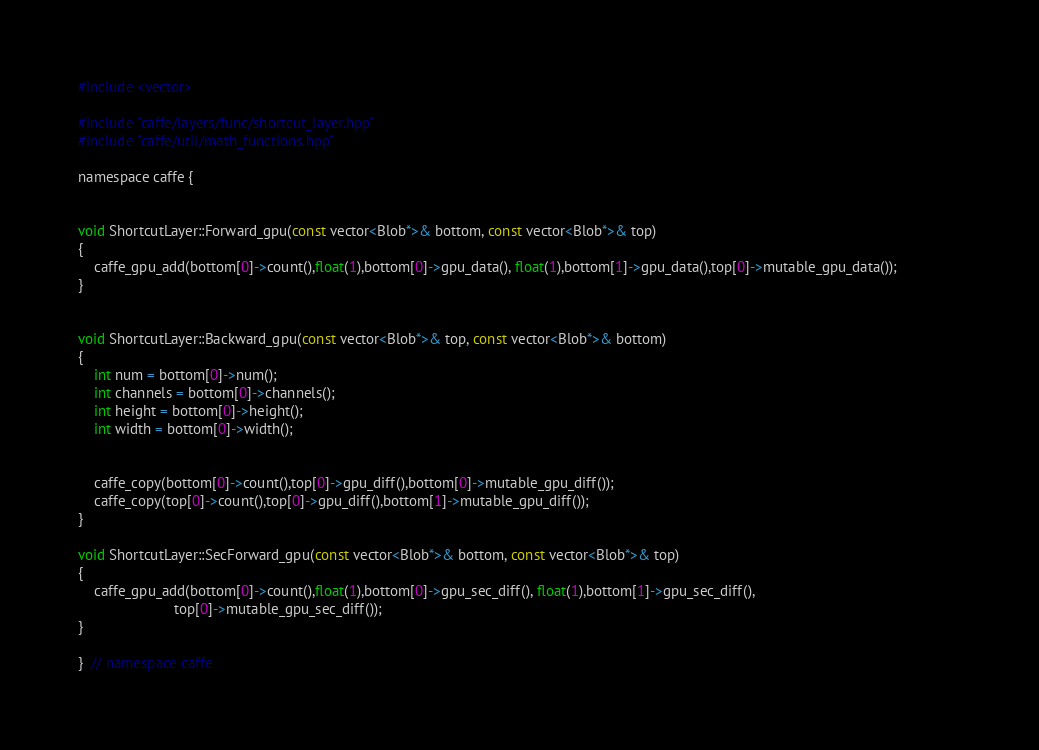<code> <loc_0><loc_0><loc_500><loc_500><_Cuda_>#include <vector>

#include "caffe/layers/func/shortcut_layer.hpp"
#include "caffe/util/math_functions.hpp"

namespace caffe {


void ShortcutLayer::Forward_gpu(const vector<Blob*>& bottom, const vector<Blob*>& top) 
{	
	caffe_gpu_add(bottom[0]->count(),float(1),bottom[0]->gpu_data(), float(1),bottom[1]->gpu_data(),top[0]->mutable_gpu_data());				
}


void ShortcutLayer::Backward_gpu(const vector<Blob*>& top, const vector<Blob*>& bottom) 
{
	int num = bottom[0]->num();
	int channels = bottom[0]->channels();
	int height = bottom[0]->height();
	int width = bottom[0]->width();


	caffe_copy(bottom[0]->count(),top[0]->gpu_diff(),bottom[0]->mutable_gpu_diff()); 
	caffe_copy(top[0]->count(),top[0]->gpu_diff(),bottom[1]->mutable_gpu_diff());
}

void ShortcutLayer::SecForward_gpu(const vector<Blob*>& bottom, const vector<Blob*>& top) 
{	
	caffe_gpu_add(bottom[0]->count(),float(1),bottom[0]->gpu_sec_diff(), float(1),bottom[1]->gpu_sec_diff(),
						top[0]->mutable_gpu_sec_diff());		
}

}  // namespace caffe
</code> 